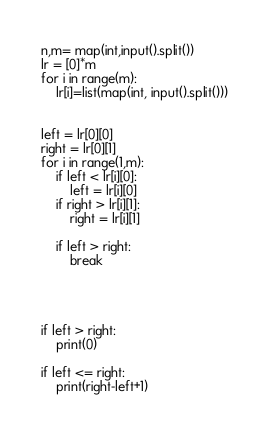Convert code to text. <code><loc_0><loc_0><loc_500><loc_500><_Python_>n,m= map(int,input().split())
lr = [0]*m
for i in range(m):
    lr[i]=list(map(int, input().split()))


left = lr[0][0]
right = lr[0][1]
for i in range(1,m):
    if left < lr[i][0]:
        left = lr[i][0]
    if right > lr[i][1]:
        right = lr[i][1]
    
    if left > right:
        break




if left > right:
    print(0)

if left <= right:
    print(right-left+1)
    

</code> 